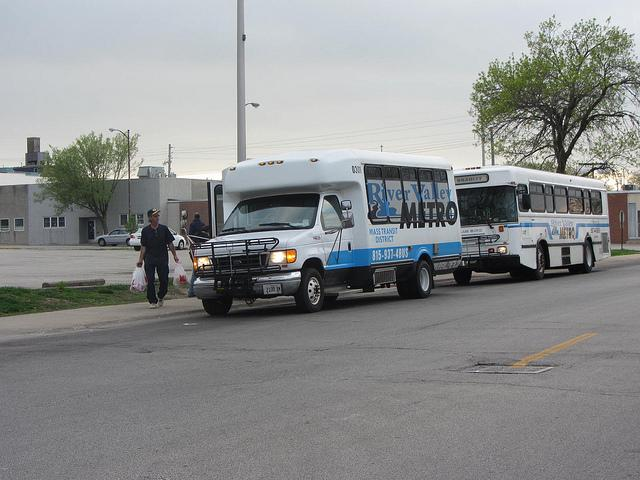What did the man on the sidewalk most likely just do? shop 